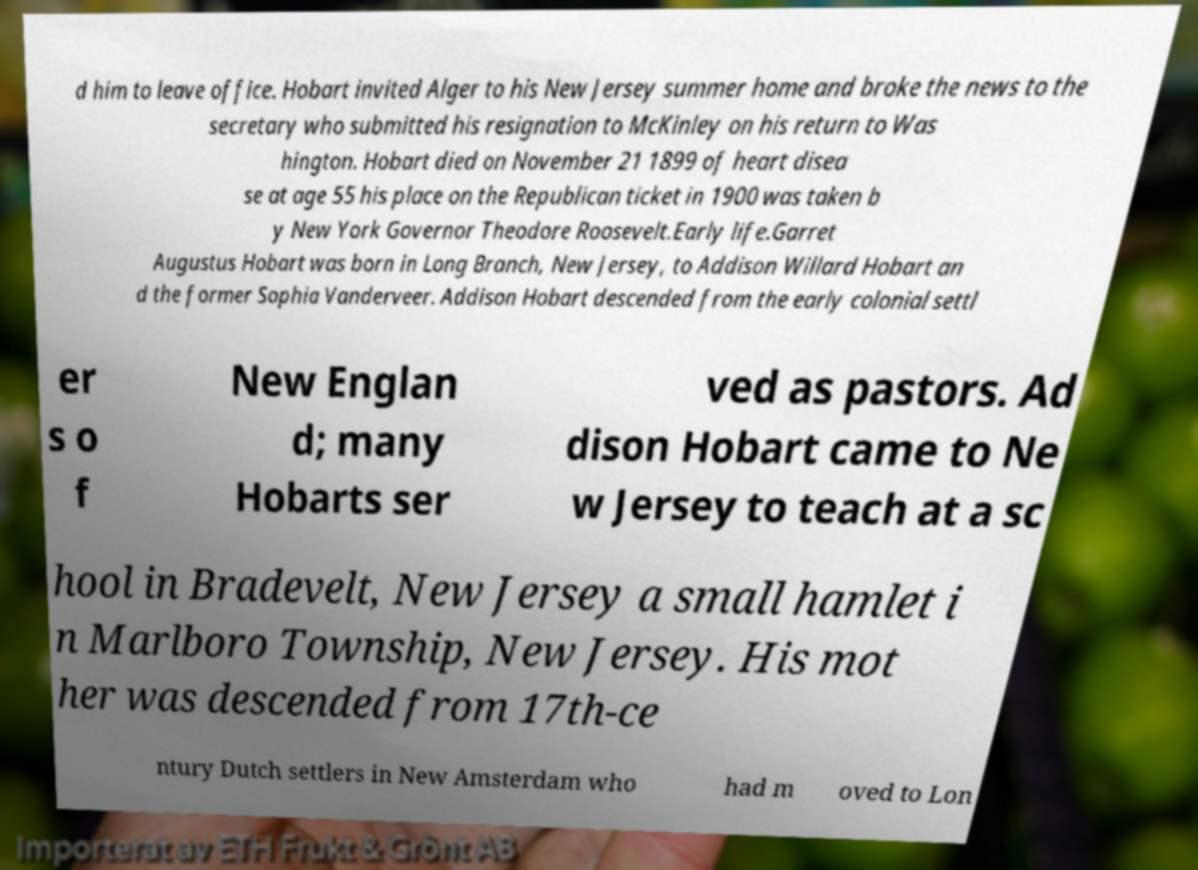For documentation purposes, I need the text within this image transcribed. Could you provide that? d him to leave office. Hobart invited Alger to his New Jersey summer home and broke the news to the secretary who submitted his resignation to McKinley on his return to Was hington. Hobart died on November 21 1899 of heart disea se at age 55 his place on the Republican ticket in 1900 was taken b y New York Governor Theodore Roosevelt.Early life.Garret Augustus Hobart was born in Long Branch, New Jersey, to Addison Willard Hobart an d the former Sophia Vanderveer. Addison Hobart descended from the early colonial settl er s o f New Englan d; many Hobarts ser ved as pastors. Ad dison Hobart came to Ne w Jersey to teach at a sc hool in Bradevelt, New Jersey a small hamlet i n Marlboro Township, New Jersey. His mot her was descended from 17th-ce ntury Dutch settlers in New Amsterdam who had m oved to Lon 